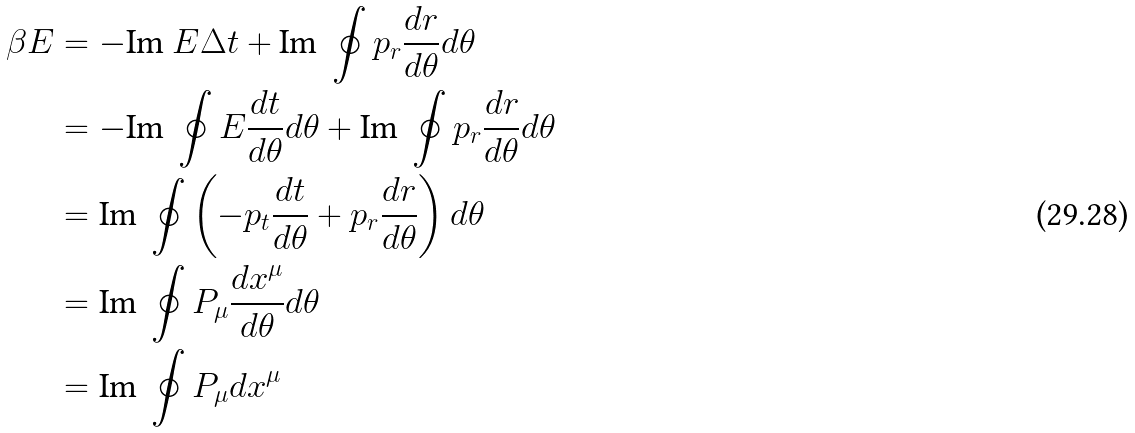<formula> <loc_0><loc_0><loc_500><loc_500>\beta E & = - \text {Im } E \Delta t + \text {Im } \oint p _ { r } \frac { d r } { d \theta } d \theta \\ & = - \text {Im } \oint E \frac { d t } { d \theta } d \theta + \text {Im } \oint p _ { r } \frac { d r } { d \theta } d \theta \\ & = \text {Im } \oint \left ( - p _ { t } \frac { d t } { d \theta } + p _ { r } \frac { d r } { d \theta } \right ) d \theta \\ & = \text {Im } \oint P _ { \mu } \frac { d x ^ { \mu } } { d \theta } d \theta \\ & = \text {Im } \oint P _ { \mu } d x ^ { \mu }</formula> 